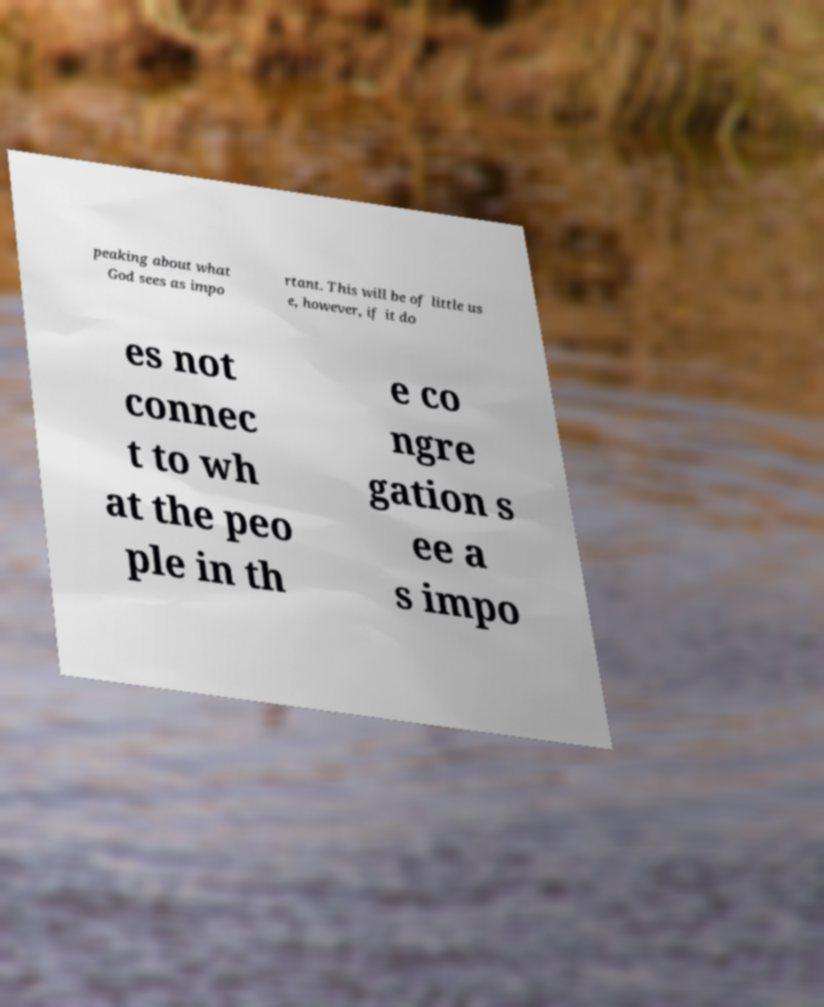I need the written content from this picture converted into text. Can you do that? peaking about what God sees as impo rtant. This will be of little us e, however, if it do es not connec t to wh at the peo ple in th e co ngre gation s ee a s impo 